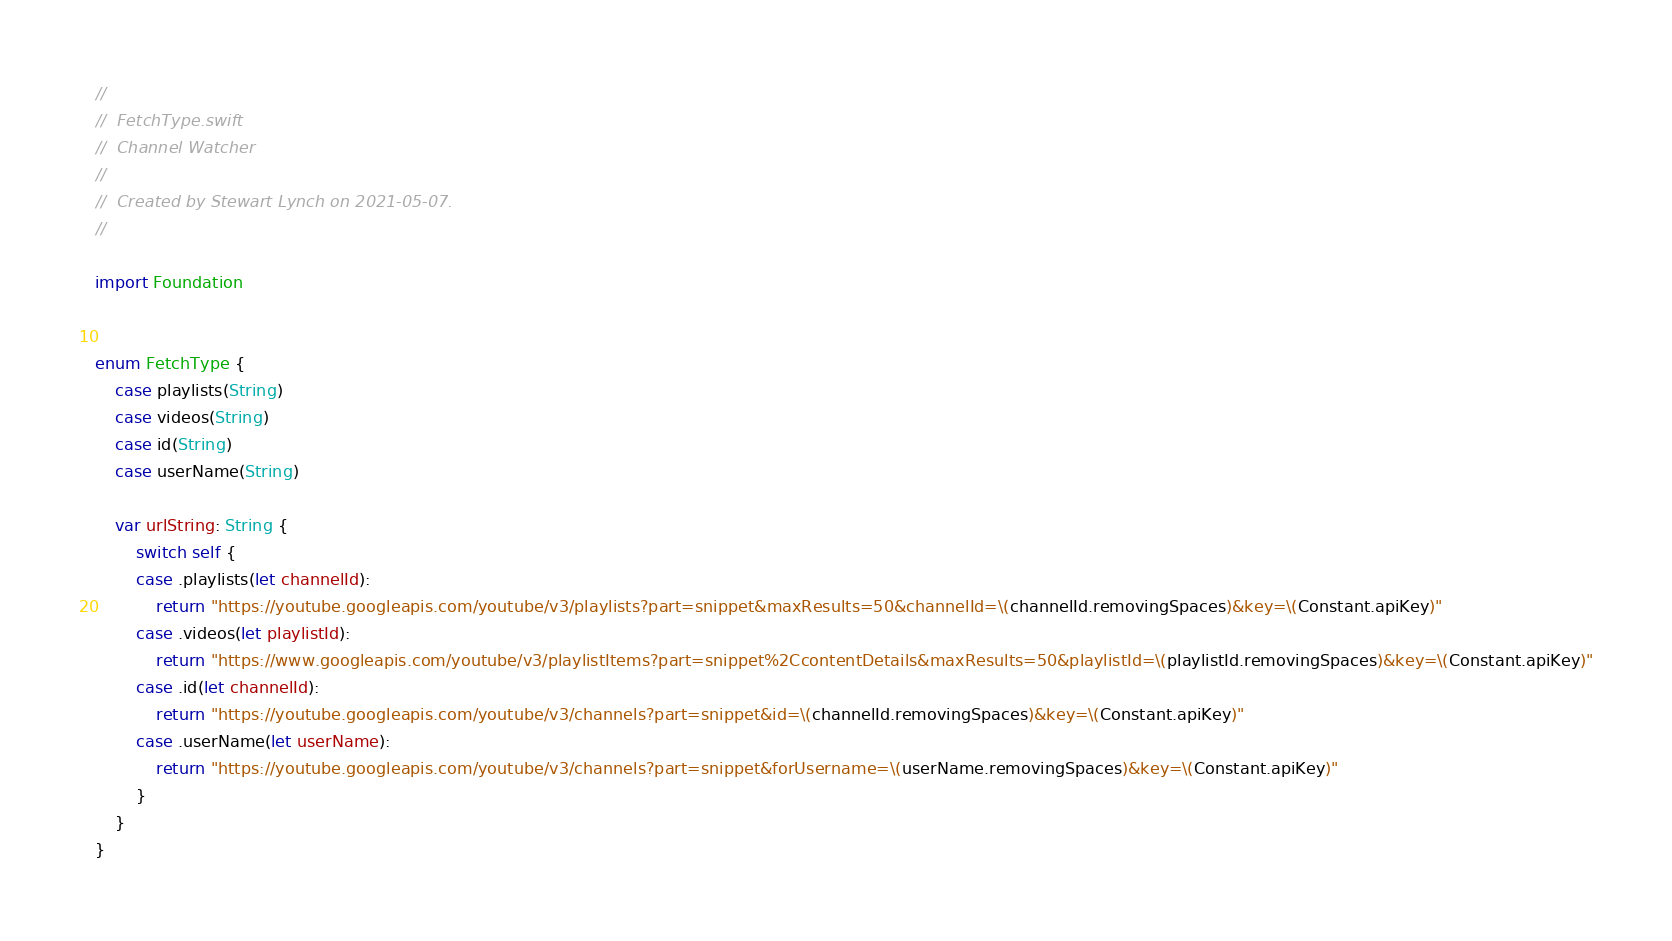Convert code to text. <code><loc_0><loc_0><loc_500><loc_500><_Swift_>//
//  FetchType.swift
//  Channel Watcher
//
//  Created by Stewart Lynch on 2021-05-07.
//

import Foundation


enum FetchType {
    case playlists(String)
    case videos(String)
    case id(String)
    case userName(String)
    
    var urlString: String {
        switch self {
        case .playlists(let channelId):
            return "https://youtube.googleapis.com/youtube/v3/playlists?part=snippet&maxResults=50&channelId=\(channelId.removingSpaces)&key=\(Constant.apiKey)"
        case .videos(let playlistId):
            return "https://www.googleapis.com/youtube/v3/playlistItems?part=snippet%2CcontentDetails&maxResults=50&playlistId=\(playlistId.removingSpaces)&key=\(Constant.apiKey)"
        case .id(let channelId):
            return "https://youtube.googleapis.com/youtube/v3/channels?part=snippet&id=\(channelId.removingSpaces)&key=\(Constant.apiKey)"
        case .userName(let userName):
            return "https://youtube.googleapis.com/youtube/v3/channels?part=snippet&forUsername=\(userName.removingSpaces)&key=\(Constant.apiKey)"
        }
    }
}
</code> 